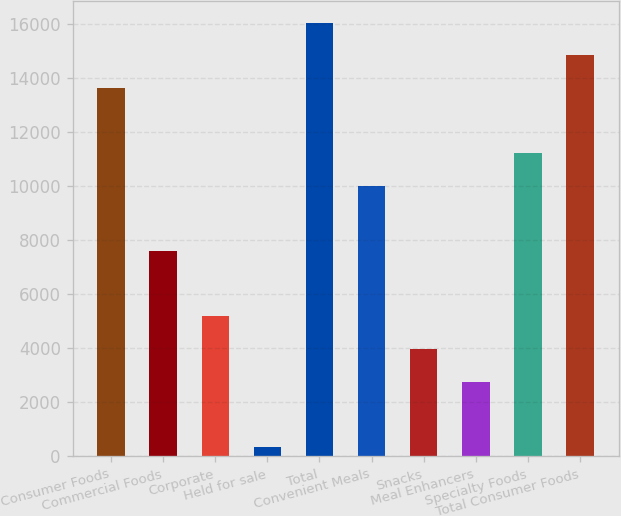Convert chart to OTSL. <chart><loc_0><loc_0><loc_500><loc_500><bar_chart><fcel>Consumer Foods<fcel>Commercial Foods<fcel>Corporate<fcel>Held for sale<fcel>Total<fcel>Convenient Meals<fcel>Snacks<fcel>Meal Enhancers<fcel>Specialty Foods<fcel>Total Consumer Foods<nl><fcel>13634.9<fcel>7590.78<fcel>5173.12<fcel>337.8<fcel>16052.6<fcel>10008.4<fcel>3964.29<fcel>2755.46<fcel>11217.3<fcel>14843.8<nl></chart> 